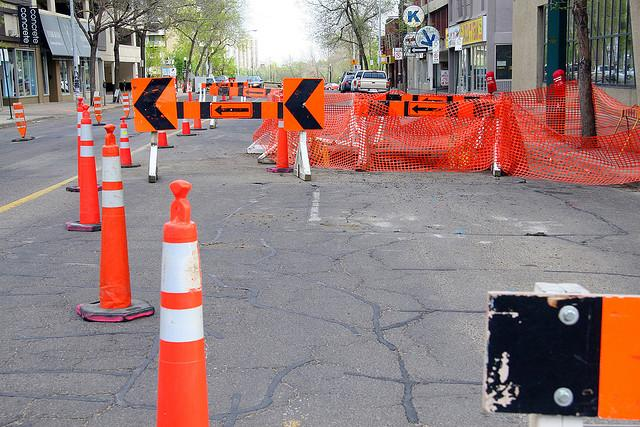Where are repairs taking place here?

Choices:
A) sidewalk only
B) street
C) automobiles
D) parking garage street 